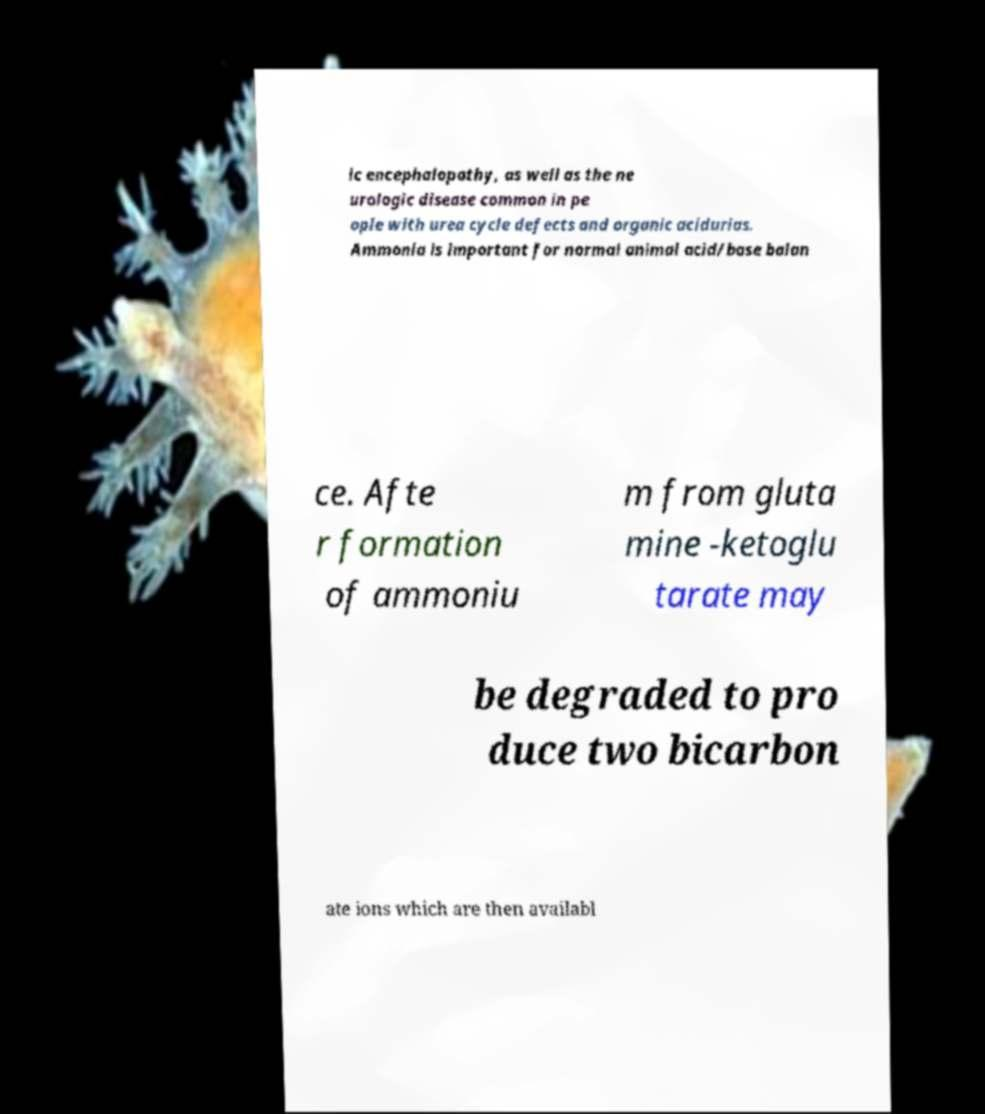Can you read and provide the text displayed in the image?This photo seems to have some interesting text. Can you extract and type it out for me? ic encephalopathy, as well as the ne urologic disease common in pe ople with urea cycle defects and organic acidurias. Ammonia is important for normal animal acid/base balan ce. Afte r formation of ammoniu m from gluta mine -ketoglu tarate may be degraded to pro duce two bicarbon ate ions which are then availabl 